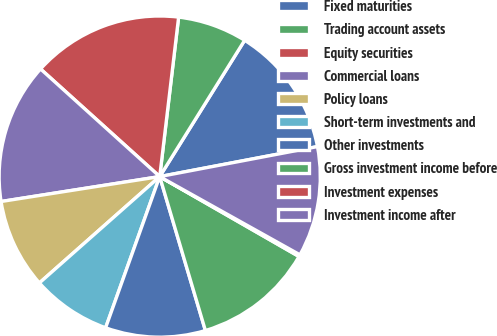Convert chart. <chart><loc_0><loc_0><loc_500><loc_500><pie_chart><fcel>Fixed maturities<fcel>Trading account assets<fcel>Equity securities<fcel>Commercial loans<fcel>Policy loans<fcel>Short-term investments and<fcel>Other investments<fcel>Gross investment income before<fcel>Investment expenses<fcel>Investment income after<nl><fcel>13.14%<fcel>6.99%<fcel>15.19%<fcel>14.17%<fcel>9.04%<fcel>8.01%<fcel>10.06%<fcel>12.12%<fcel>0.19%<fcel>11.09%<nl></chart> 